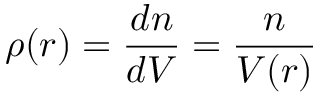Convert formula to latex. <formula><loc_0><loc_0><loc_500><loc_500>\rho ( r ) = \frac { d n } { d V } = \frac { n } { V ( r ) }</formula> 